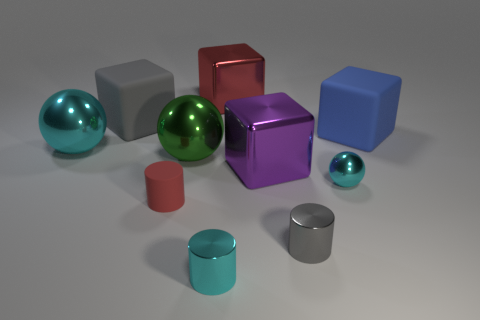Subtract all balls. How many objects are left? 7 Subtract 1 cyan cylinders. How many objects are left? 9 Subtract all large purple metal blocks. Subtract all tiny things. How many objects are left? 5 Add 2 tiny gray cylinders. How many tiny gray cylinders are left? 3 Add 9 purple objects. How many purple objects exist? 10 